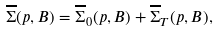Convert formula to latex. <formula><loc_0><loc_0><loc_500><loc_500>\overline { \Sigma } ( p , B ) = \overline { \Sigma } _ { 0 } ( p , B ) + \overline { \Sigma } _ { T } ( p , B ) ,</formula> 